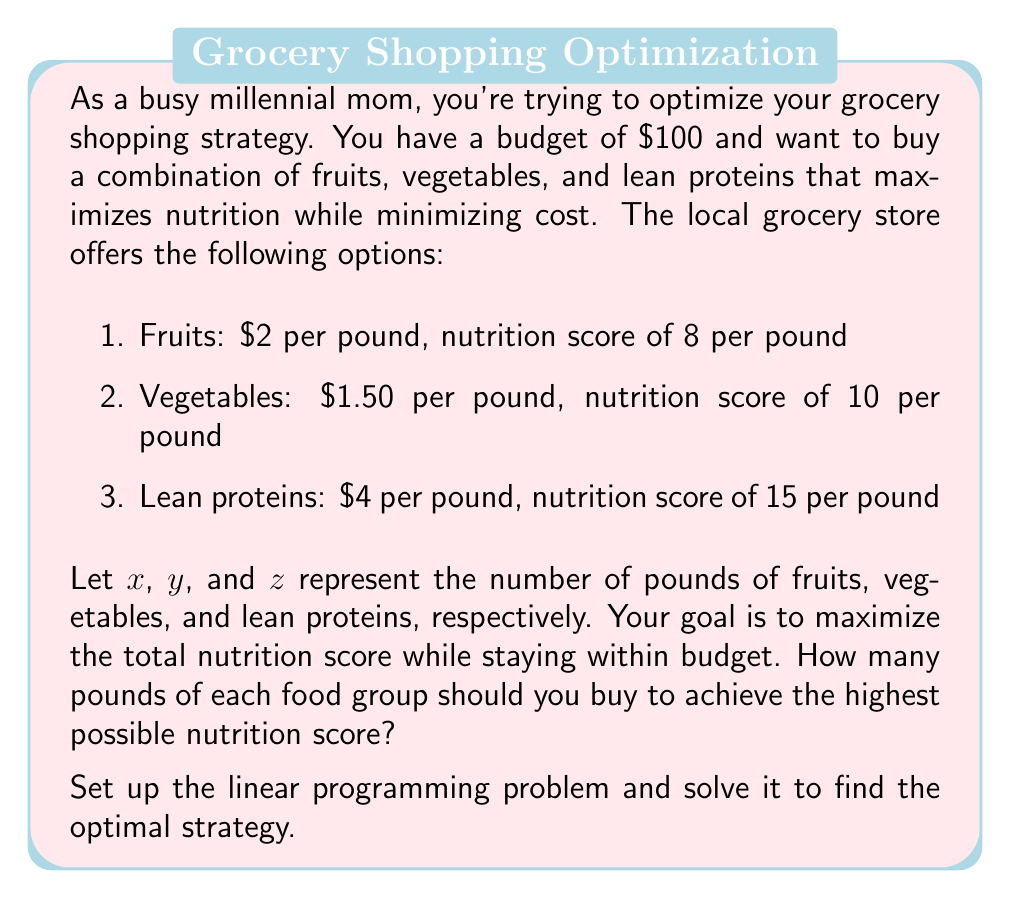Provide a solution to this math problem. To solve this problem, we need to set up a linear programming model and then solve it. Let's break it down step-by-step:

1. Define the objective function:
We want to maximize the total nutrition score, which is given by:
$$ 8x + 10y + 15z $$

2. Set up the constraints:
a) Budget constraint: The total cost must not exceed $100
$$ 2x + 1.5y + 4z \leq 100 $$

b) Non-negativity constraints: We can't buy negative amounts of food
$$ x \geq 0, y \geq 0, z \geq 0 $$

3. Solve the linear programming problem:
We can solve this using the simplex method or graphical method. In this case, we'll use the graphical method as it's easier to visualize.

4. Plot the constraints:
The budget constraint is:
$$ 2x + 1.5y + 4z = 100 $$

We can visualize this in 2D by setting $z = 0$:
$$ 2x + 1.5y = 100 $$
$$ y = \frac{200}{3} - \frac{4}{3}x $$

5. Find the vertices:
The vertices of the feasible region are:
(0, 0, 0), (50, 0, 0), (0, 66.67, 0), and (0, 0, 25)

6. Evaluate the objective function at each vertex:
- (0, 0, 0): $8(0) + 10(0) + 15(0) = 0$
- (50, 0, 0): $8(50) + 10(0) + 15(0) = 400$
- (0, 66.67, 0): $8(0) + 10(66.67) + 15(0) = 666.7$
- (0, 0, 25): $8(0) + 10(0) + 15(25) = 375$

The maximum value is achieved at the point (0, 66.67, 0), which corresponds to buying only vegetables.

7. Round the result:
Since we can't buy fractional pounds, we'll round down to 66 pounds of vegetables.
Answer: The optimal strategy is to buy 66 pounds of vegetables, which will result in a nutrition score of 660 while staying within the $100 budget. 